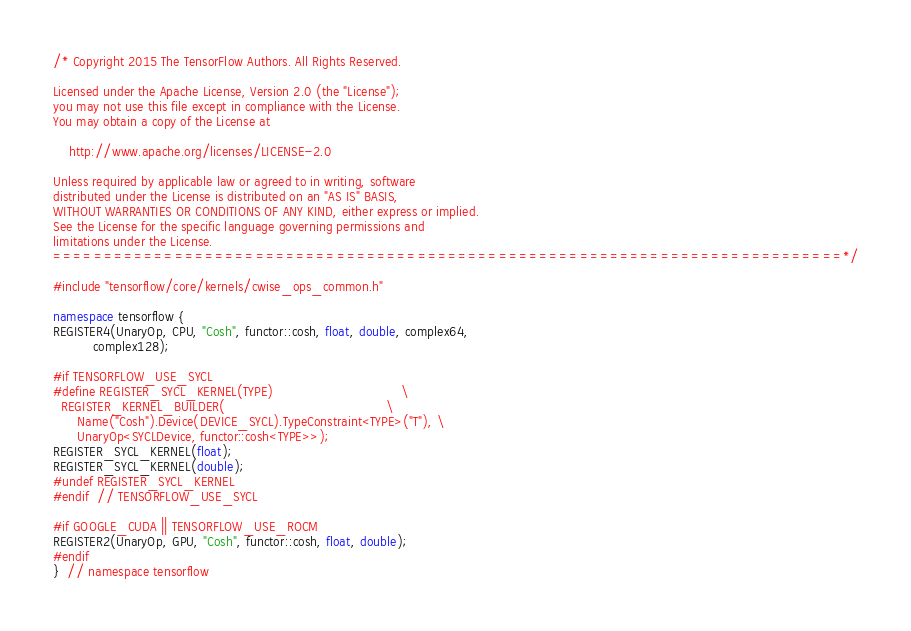Convert code to text. <code><loc_0><loc_0><loc_500><loc_500><_C++_>/* Copyright 2015 The TensorFlow Authors. All Rights Reserved.

Licensed under the Apache License, Version 2.0 (the "License");
you may not use this file except in compliance with the License.
You may obtain a copy of the License at

    http://www.apache.org/licenses/LICENSE-2.0

Unless required by applicable law or agreed to in writing, software
distributed under the License is distributed on an "AS IS" BASIS,
WITHOUT WARRANTIES OR CONDITIONS OF ANY KIND, either express or implied.
See the License for the specific language governing permissions and
limitations under the License.
==============================================================================*/

#include "tensorflow/core/kernels/cwise_ops_common.h"

namespace tensorflow {
REGISTER4(UnaryOp, CPU, "Cosh", functor::cosh, float, double, complex64,
          complex128);

#if TENSORFLOW_USE_SYCL
#define REGISTER_SYCL_KERNEL(TYPE)                                \
  REGISTER_KERNEL_BUILDER(                                        \
      Name("Cosh").Device(DEVICE_SYCL).TypeConstraint<TYPE>("T"), \
      UnaryOp<SYCLDevice, functor::cosh<TYPE>>);
REGISTER_SYCL_KERNEL(float);
REGISTER_SYCL_KERNEL(double);
#undef REGISTER_SYCL_KERNEL
#endif  // TENSORFLOW_USE_SYCL

#if GOOGLE_CUDA || TENSORFLOW_USE_ROCM
REGISTER2(UnaryOp, GPU, "Cosh", functor::cosh, float, double);
#endif
}  // namespace tensorflow
</code> 